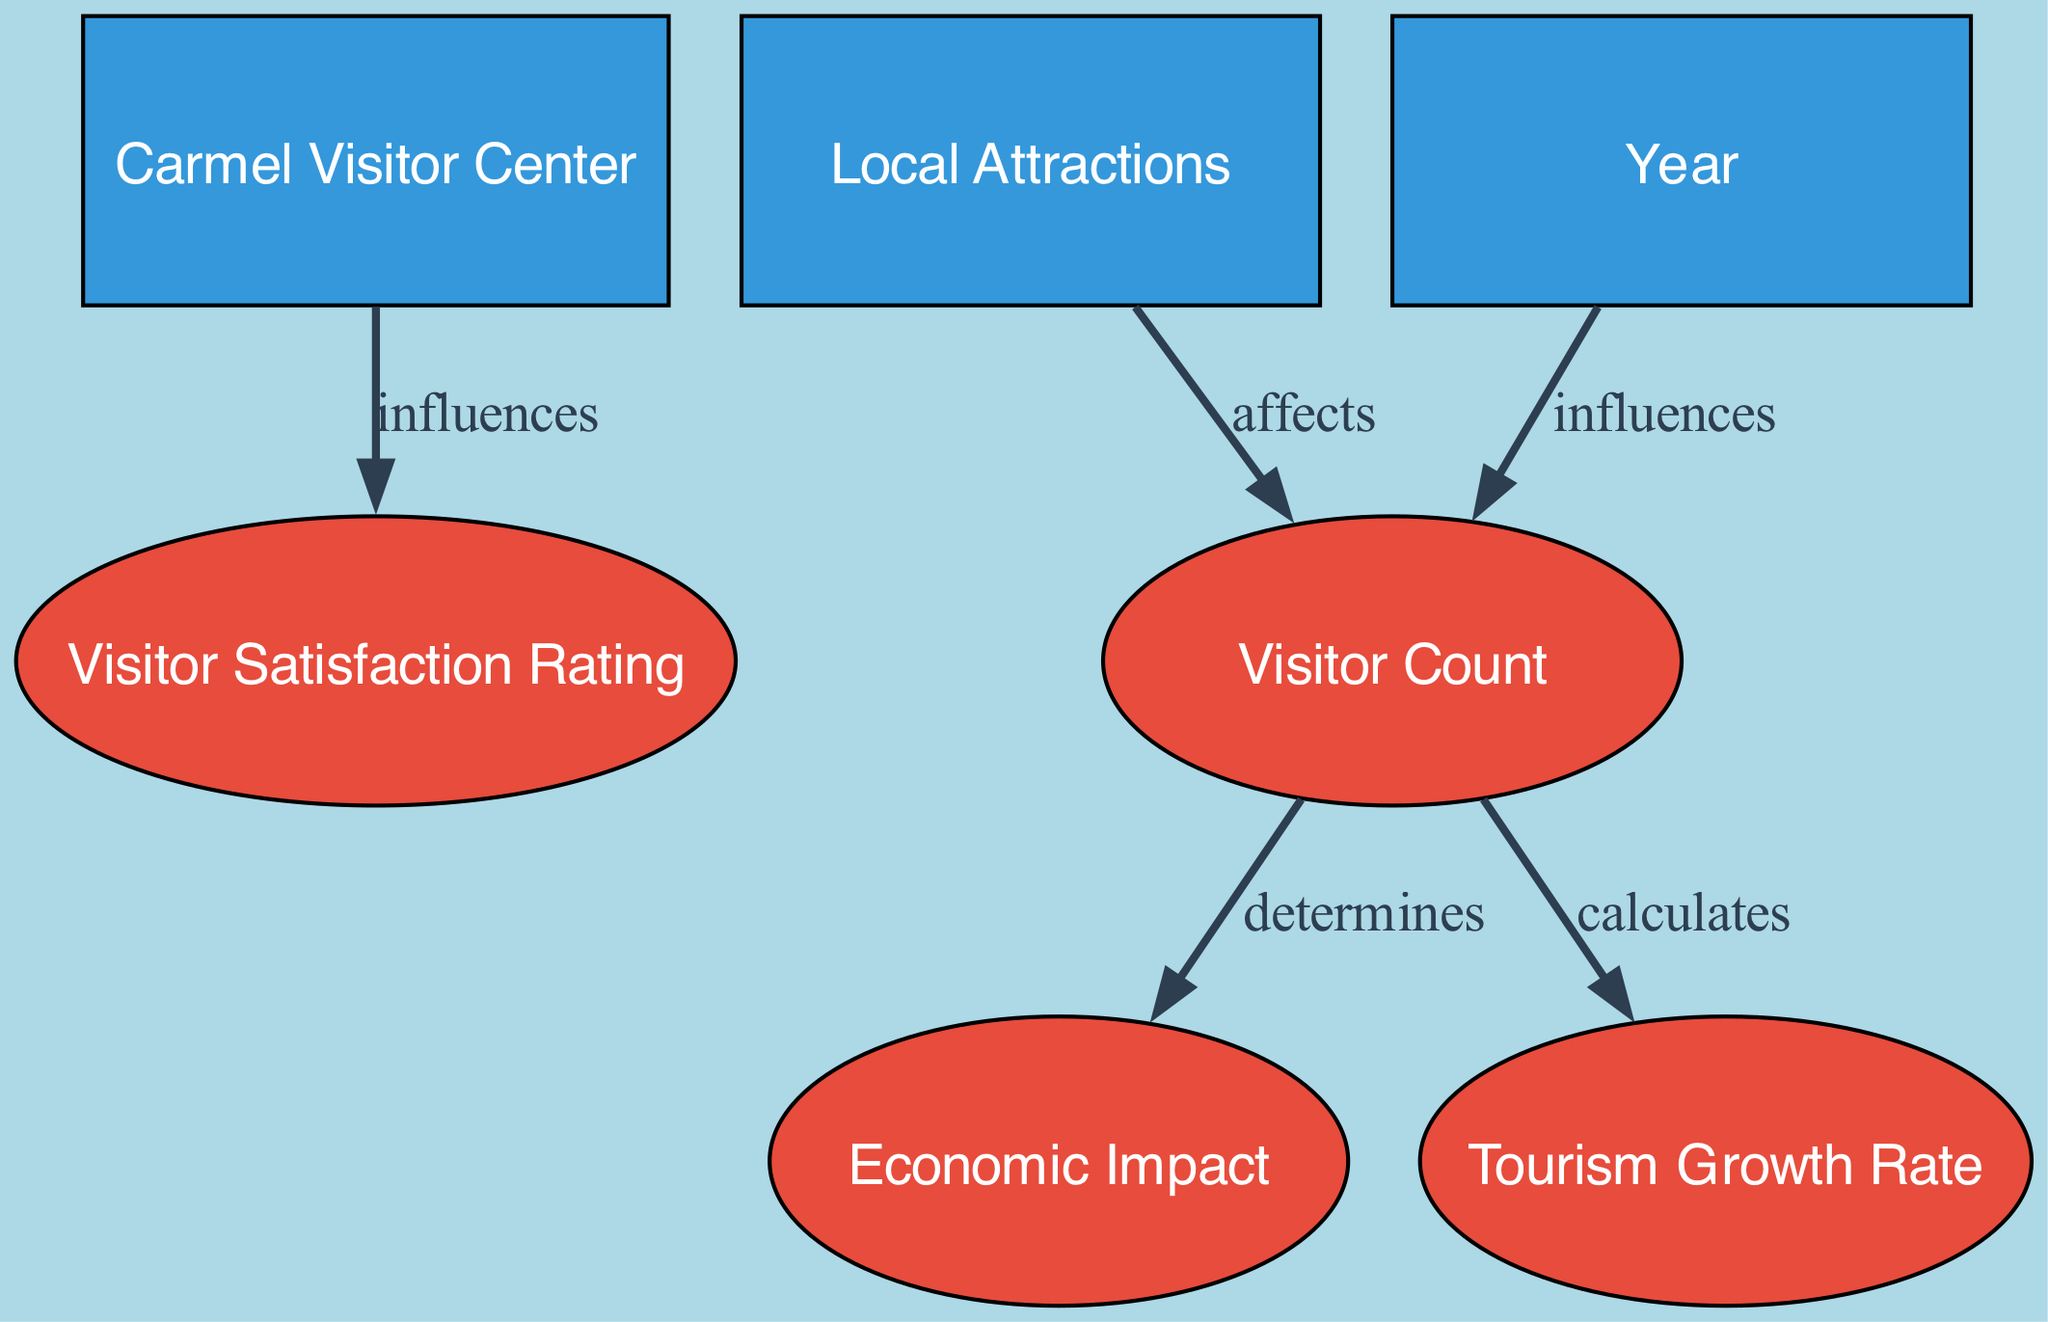What's the total number of entities in the diagram? The diagram lists six distinct elements, all of which are categorized as entities. This includes "Carmel Visitor Center," "Local Attractions," and "Year."
Answer: six What does the node "Year" influence? The "Year" node has a directed edge pointing to the "Visitor Count," indicating that it influences the total number of visitors registered in a specific year.
Answer: Visitor Count Which node determines the "Economic Impact"? The "Visitor Count" node is directly connected to the "Economic Impact" node via a directed edge that indicates it determines the economic contribution from tourism.
Answer: Visitor Count What color represents metric nodes in the diagram? The color scheme indicates that metric nodes are represented in a red shade. The specific color designated for metrics is #e74c3c.
Answer: red What relationship exists between "Carmel Visitor Center" and "Visitor Satisfaction Rating"? There is a directed edge from "Carmel Visitor Center" to "Visitor Satisfaction Rating," indicating an influence. This suggests that the quality of information and services provided by the Visitor Center affects visitor satisfaction.
Answer: influences How is the "Tourism Growth Rate" calculated? The "Tourism Growth Rate" is calculated based on the values from the "Visitor Count," which means that the percentage increase in visitor numbers year-on-year is derived from the visitor statistics.
Answer: calculates Is there a direct correlation between "Visitor Count" and "Visitor Satisfaction Rating"? The diagram does not explicitly indicate a direct correlation between "Visitor Count" and "Visitor Satisfaction Rating." Rather, the Visitor Center influences satisfaction, and the Visitor Count affects economic impact and growth rate, but not directly on satisfaction.
Answer: no What is the relationship between "Local Attractions" and "Visitor Count"? The directed edge from "Local Attractions" to "Visitor Count" denotes that local attractions affect the number of visitors to Carmel-by-the-Sea, as more attractions may draw more tourists.
Answer: affects How many edges connect to the "Visitor Count" node? The "Visitor Count" node has three outgoing edges connecting it to other nodes, indicating the relationships it holds with "Economic Impact," "Tourism Growth Rate," and ties back to the "Year."
Answer: three 